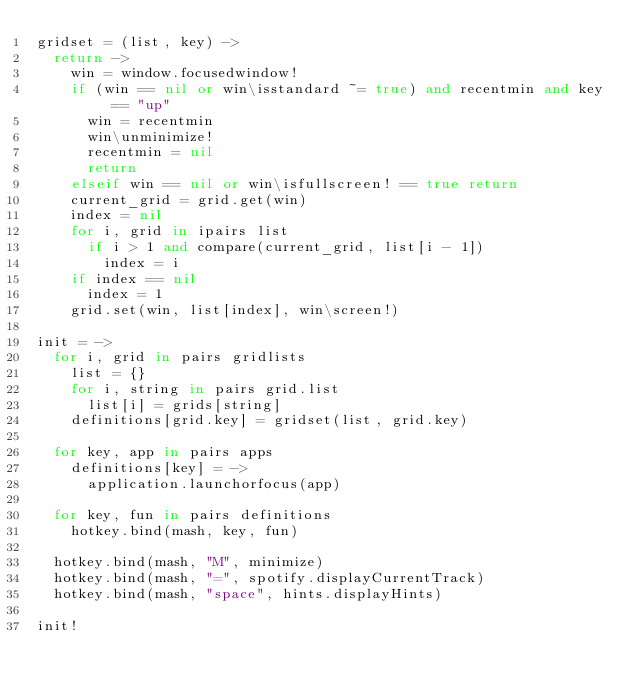Convert code to text. <code><loc_0><loc_0><loc_500><loc_500><_MoonScript_>gridset = (list, key) ->
  return ->
    win = window.focusedwindow!
    if (win == nil or win\isstandard ~= true) and recentmin and key == "up"
      win = recentmin
      win\unminimize!
      recentmin = nil
      return
    elseif win == nil or win\isfullscreen! == true return
    current_grid = grid.get(win)
    index = nil
    for i, grid in ipairs list
      if i > 1 and compare(current_grid, list[i - 1])
        index = i
    if index == nil
      index = 1
    grid.set(win, list[index], win\screen!)

init = ->
  for i, grid in pairs gridlists
    list = {}
    for i, string in pairs grid.list
      list[i] = grids[string]
    definitions[grid.key] = gridset(list, grid.key)

  for key, app in pairs apps
    definitions[key] = ->
      application.launchorfocus(app)

  for key, fun in pairs definitions
    hotkey.bind(mash, key, fun)

  hotkey.bind(mash, "M", minimize)
  hotkey.bind(mash, "=", spotify.displayCurrentTrack)
  hotkey.bind(mash, "space", hints.displayHints)

init!
</code> 